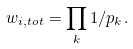Convert formula to latex. <formula><loc_0><loc_0><loc_500><loc_500>w _ { i , t o t } = \prod _ { k } 1 / p _ { k } .</formula> 